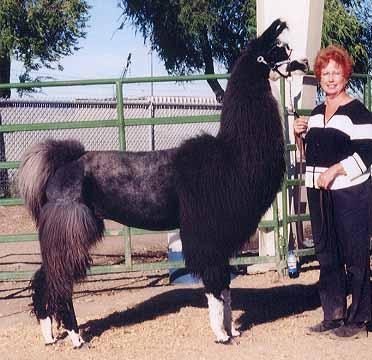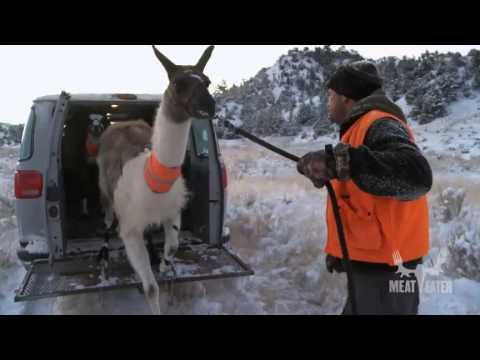The first image is the image on the left, the second image is the image on the right. Examine the images to the left and right. Is the description "An image shows a back-turned standing person on the right pulling a rope attached to a llama in front of an open wheeled hauler." accurate? Answer yes or no. Yes. The first image is the image on the left, the second image is the image on the right. Considering the images on both sides, is "In at least one image there is a man leading a llama away from the back of a vehicle." valid? Answer yes or no. Yes. 